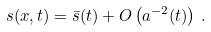<formula> <loc_0><loc_0><loc_500><loc_500>s ( { x } , t ) = \bar { s } ( t ) + O \left ( a ^ { - 2 } ( t ) \right ) \, .</formula> 